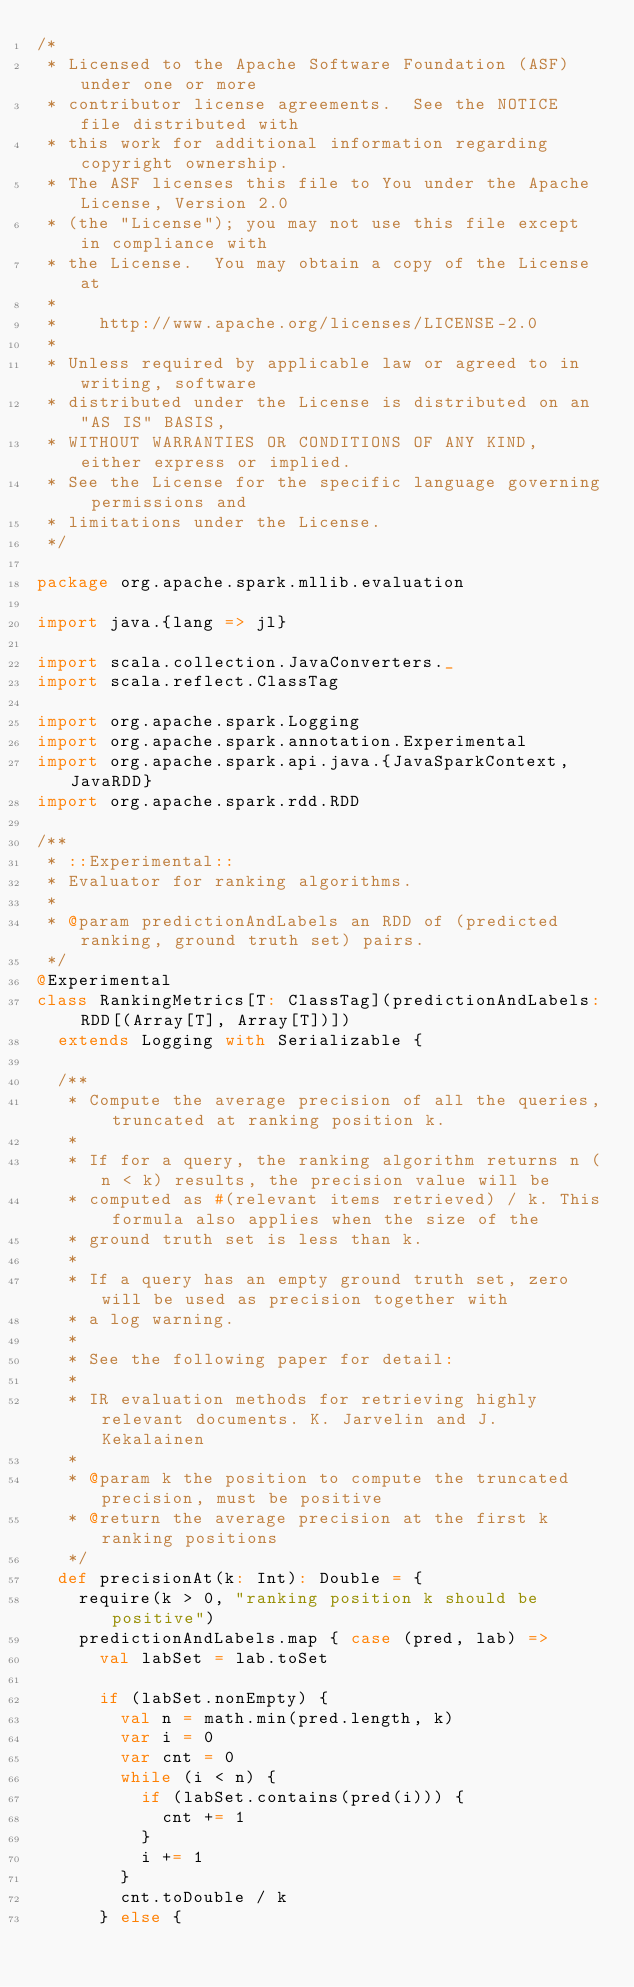<code> <loc_0><loc_0><loc_500><loc_500><_Scala_>/*
 * Licensed to the Apache Software Foundation (ASF) under one or more
 * contributor license agreements.  See the NOTICE file distributed with
 * this work for additional information regarding copyright ownership.
 * The ASF licenses this file to You under the Apache License, Version 2.0
 * (the "License"); you may not use this file except in compliance with
 * the License.  You may obtain a copy of the License at
 *
 *    http://www.apache.org/licenses/LICENSE-2.0
 *
 * Unless required by applicable law or agreed to in writing, software
 * distributed under the License is distributed on an "AS IS" BASIS,
 * WITHOUT WARRANTIES OR CONDITIONS OF ANY KIND, either express or implied.
 * See the License for the specific language governing permissions and
 * limitations under the License.
 */

package org.apache.spark.mllib.evaluation

import java.{lang => jl}

import scala.collection.JavaConverters._
import scala.reflect.ClassTag

import org.apache.spark.Logging
import org.apache.spark.annotation.Experimental
import org.apache.spark.api.java.{JavaSparkContext, JavaRDD}
import org.apache.spark.rdd.RDD

/**
 * ::Experimental::
 * Evaluator for ranking algorithms.
 *
 * @param predictionAndLabels an RDD of (predicted ranking, ground truth set) pairs.
 */
@Experimental
class RankingMetrics[T: ClassTag](predictionAndLabels: RDD[(Array[T], Array[T])])
  extends Logging with Serializable {

  /**
   * Compute the average precision of all the queries, truncated at ranking position k.
   *
   * If for a query, the ranking algorithm returns n (n < k) results, the precision value will be
   * computed as #(relevant items retrieved) / k. This formula also applies when the size of the
   * ground truth set is less than k.
   *
   * If a query has an empty ground truth set, zero will be used as precision together with
   * a log warning.
   *
   * See the following paper for detail:
   *
   * IR evaluation methods for retrieving highly relevant documents. K. Jarvelin and J. Kekalainen
   *
   * @param k the position to compute the truncated precision, must be positive
   * @return the average precision at the first k ranking positions
   */
  def precisionAt(k: Int): Double = {
    require(k > 0, "ranking position k should be positive")
    predictionAndLabels.map { case (pred, lab) =>
      val labSet = lab.toSet

      if (labSet.nonEmpty) {
        val n = math.min(pred.length, k)
        var i = 0
        var cnt = 0
        while (i < n) {
          if (labSet.contains(pred(i))) {
            cnt += 1
          }
          i += 1
        }
        cnt.toDouble / k
      } else {</code> 